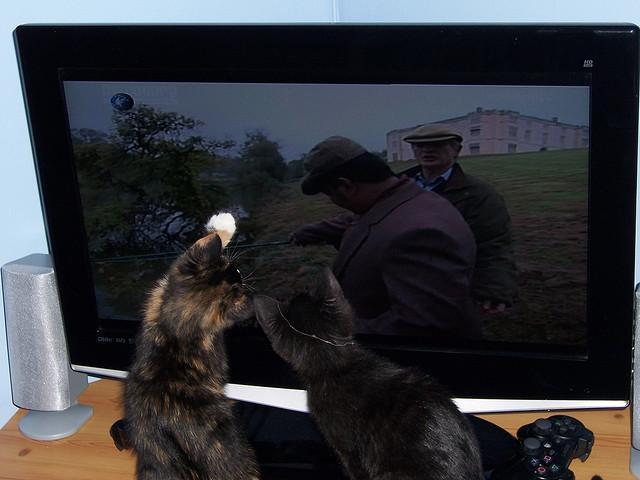How many people are in the picture?
Give a very brief answer. 2. How many cats are there?
Give a very brief answer. 2. How many motorcycles are between the sidewalk and the yellow line in the road?
Give a very brief answer. 0. 